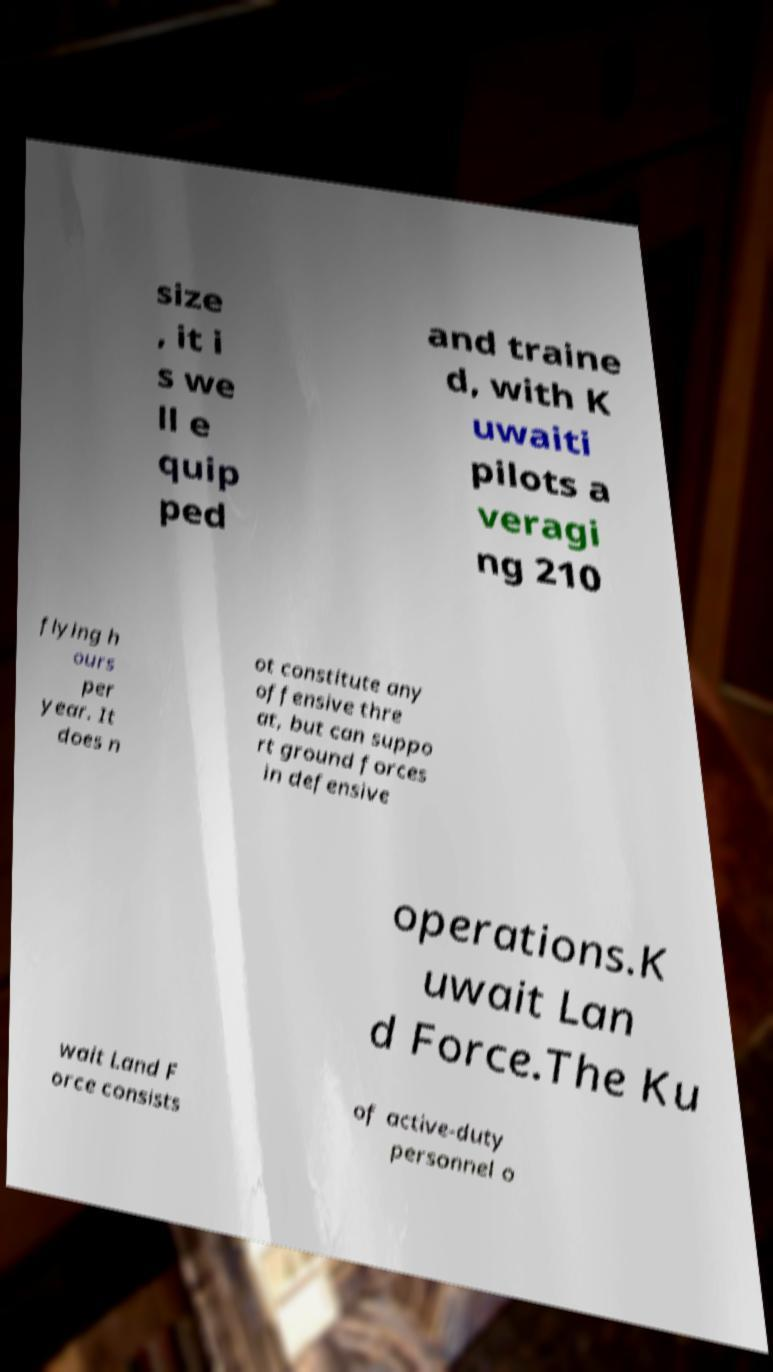Could you extract and type out the text from this image? size , it i s we ll e quip ped and traine d, with K uwaiti pilots a veragi ng 210 flying h ours per year. It does n ot constitute any offensive thre at, but can suppo rt ground forces in defensive operations.K uwait Lan d Force.The Ku wait Land F orce consists of active-duty personnel o 